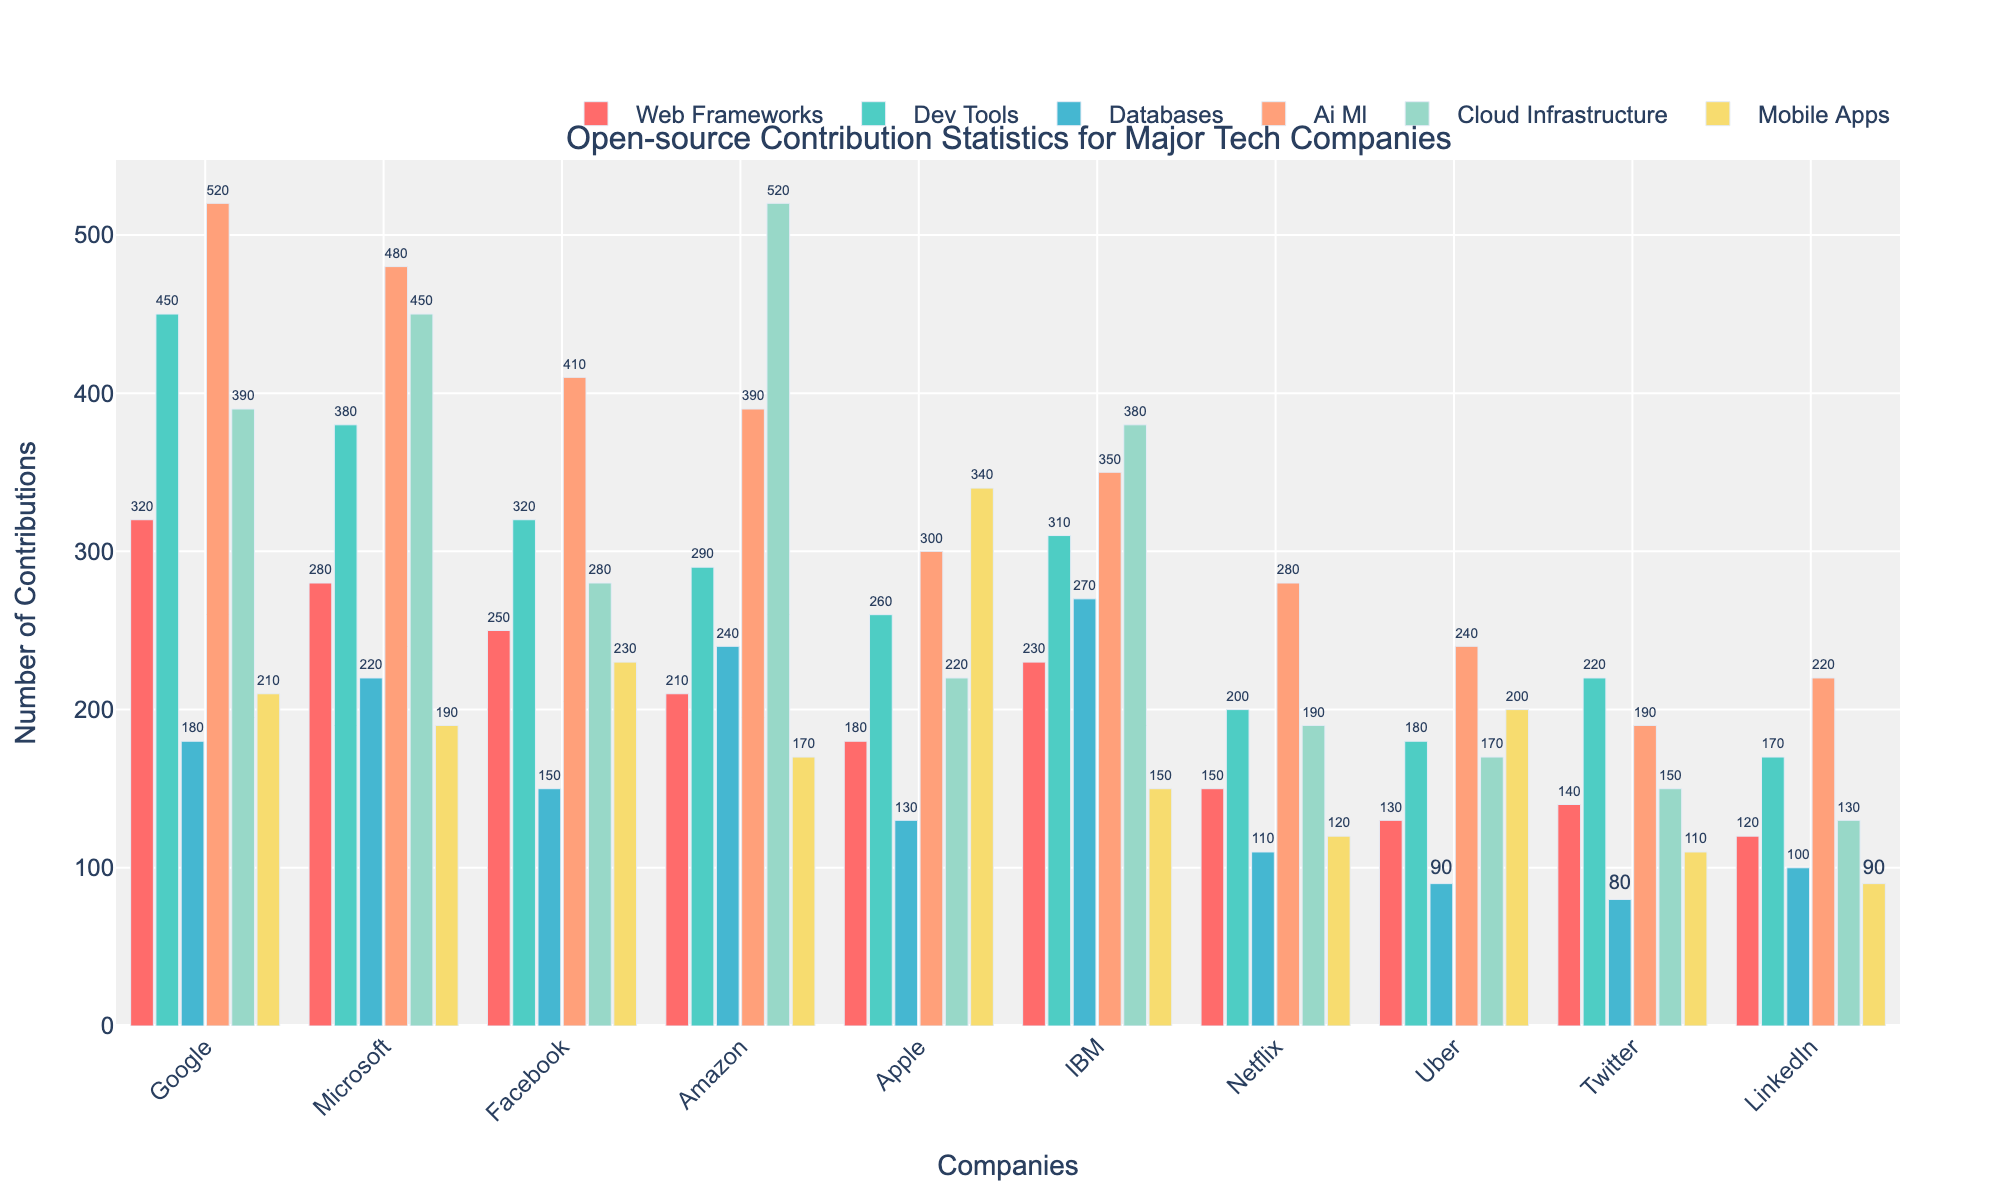Which company has the highest number of AI/ML contributions? To find this, look at the bar heights for each company in the AI/ML category. The tallest bar indicates the company with the highest contributions.
Answer: Google Which company has the lowest number of mobile app contributions? Find the shortest bar in the mobile apps category and identify which company it belongs to.
Answer: LinkedIn What is the total number of cloud infrastructure contributions by Google and Amazon combined? Add the number of contributions from Google in the cloud infrastructure category (390) to Amazon's contributions in the same category (520). 390 + 520 = 910
Answer: 910 Compare Microsoft and Facebook in terms of their contributions to dev tools. Which company has higher contributions, and by how much? Look at the bar heights for Microsoft and Facebook in the dev tools category. Microsoft has 380 contributions, and Facebook has 320 contributions. Subtract Facebook's contributions from Microsoft's. 380 - 320 = 60
Answer: Microsoft by 60 What is the average number of contributions in the databases category across all companies? Add the contributions for all companies in the databases category: 180 (Google) + 220 (Microsoft) + 150 (Facebook) + 240 (Amazon) + 130 (Apple) + 270 (IBM) + 110 (Netflix) + 90 (Uber) + 80 (Twitter) + 100 (LinkedIn). The sum is 1870. Then divide by the number of companies, which is 10. 1870 / 10 = 187
Answer: 187 Which project type sees the most contributions from IBM? Look at the bars for IBM across all project types and identify the tallest one.
Answer: Databases Which two companies have the closest contributions in the web frameworks category, and what are their contributions? Compare the heights of the bars in the web frameworks category for each company. Twitter (140) and LinkedIn (120) have the closest contributions.
Answer: Twitter: 140, LinkedIn: 120 For which project type is there the largest variability in contributions among the companies? Look at the bars for each project type and identify where the difference between the highest and lowest bars is the greatest. This involves visually comparing the spreads in each category. The AI/ML project type shows the largest variability.
Answer: AI/ML By how much do Facebook's contributions to mobile apps exceed Amazon's? Look at the bars in the mobile apps category for Facebook and Amazon. Facebook has 230 contributions and Amazon has 170. Subtract Amazon's contributions from Facebook's. 230 - 170 = 60
Answer: 60 What is the sum of contributions made by Twitter across all project types? Add Twitter's contributions in each project type: 140 (web frameworks) + 220 (dev tools) + 80 (databases) + 190 (AI/ML) + 150 (cloud infrastructure) + 110 (mobile apps). The sum is 890.
Answer: 890 